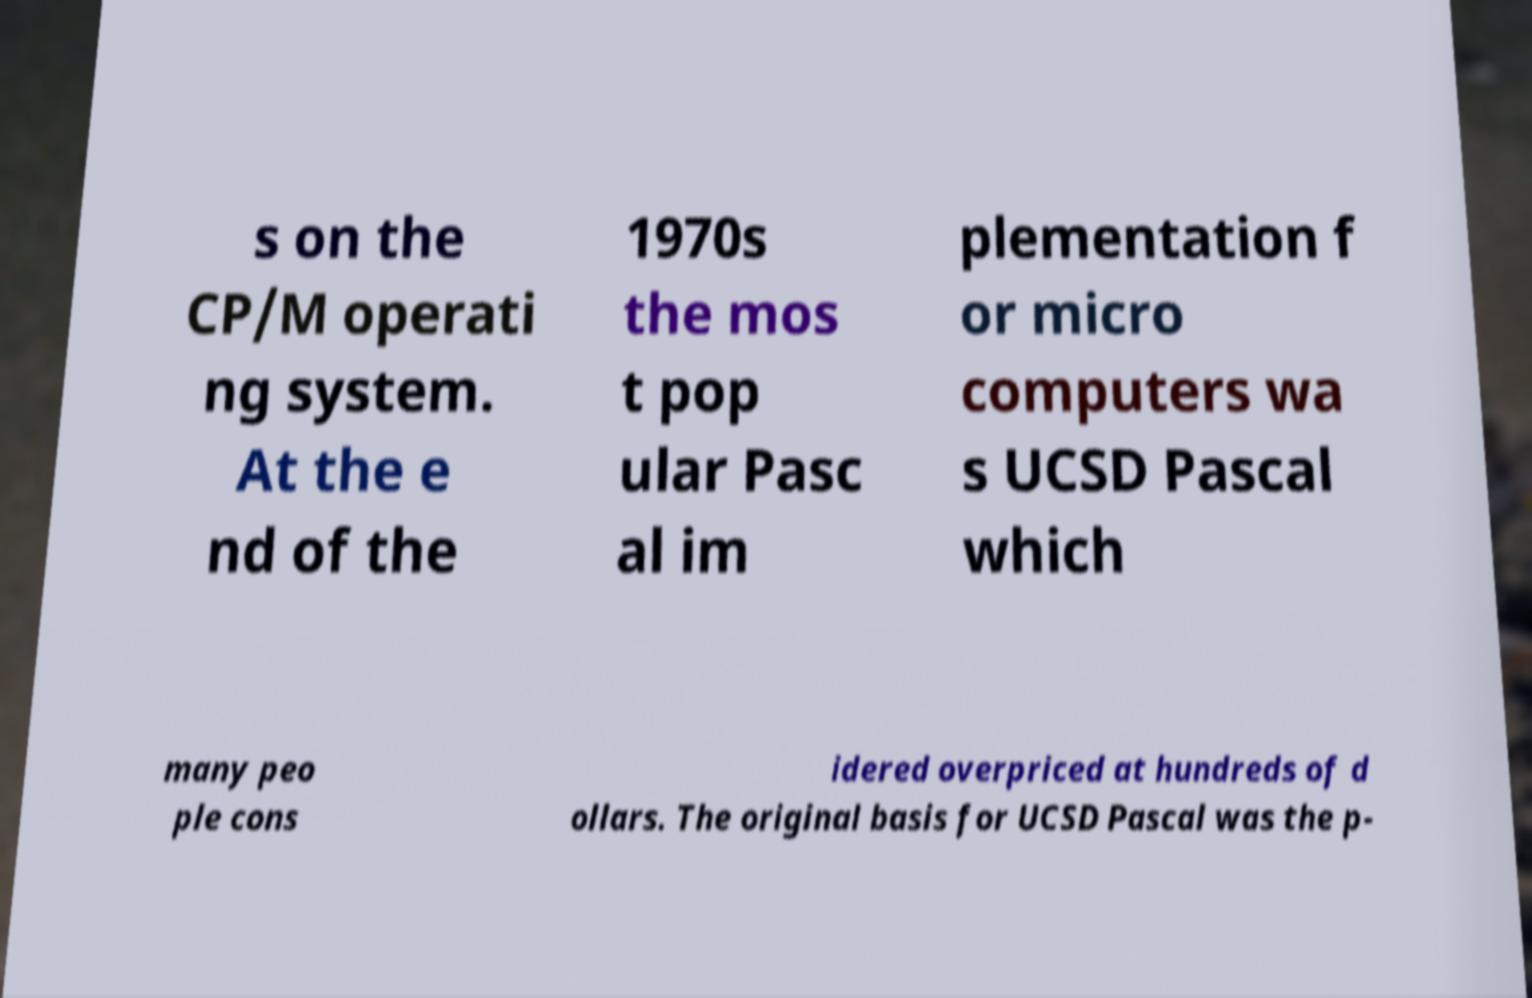Please identify and transcribe the text found in this image. s on the CP/M operati ng system. At the e nd of the 1970s the mos t pop ular Pasc al im plementation f or micro computers wa s UCSD Pascal which many peo ple cons idered overpriced at hundreds of d ollars. The original basis for UCSD Pascal was the p- 